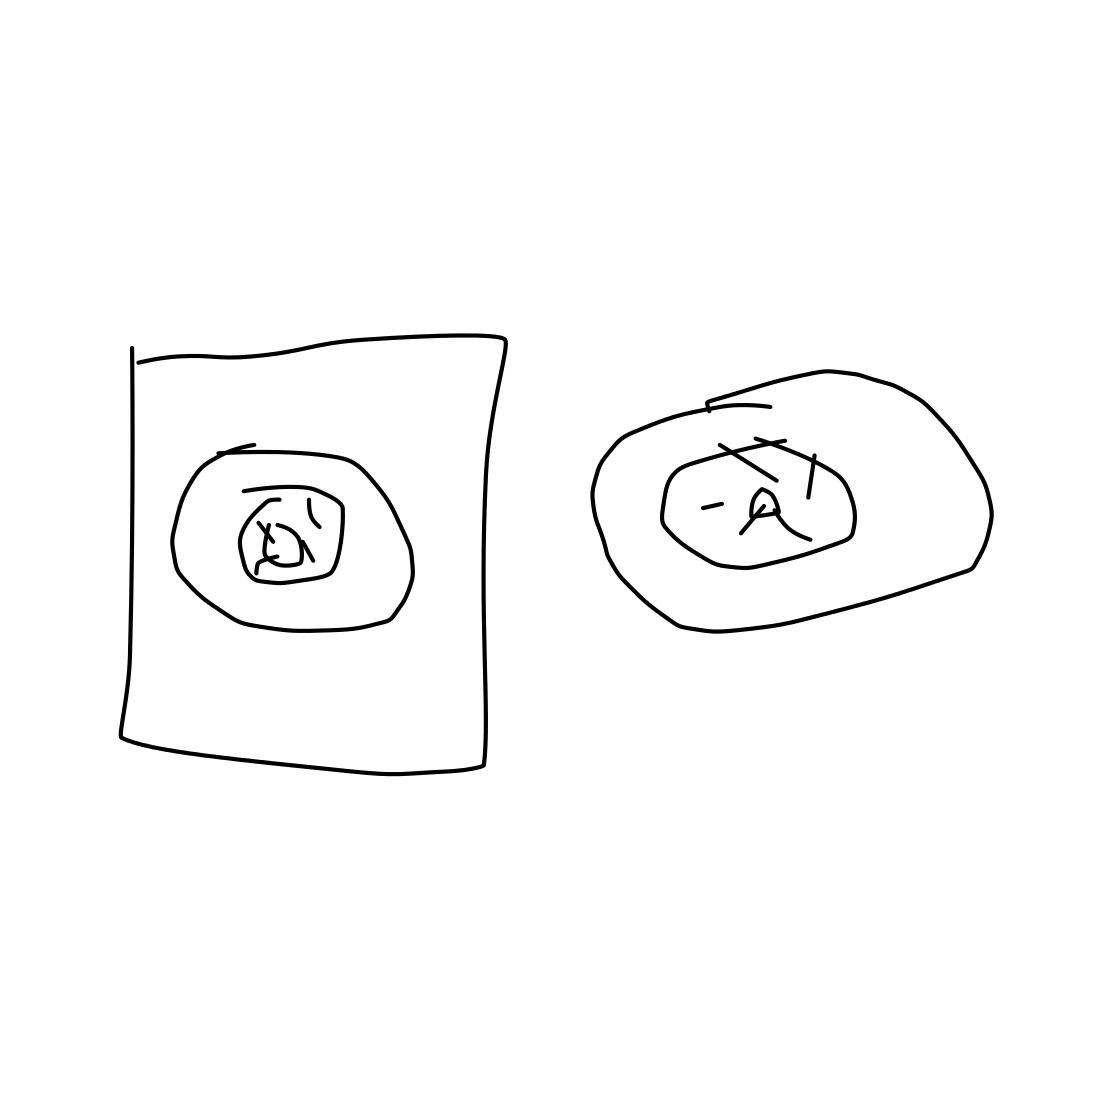Do these sketches appear to be part of a larger project or idea? Given their simplicity and the lack of additional information, it's hard to determine if they're part of a larger project. They might be standalone ideas or components of a sequence. Additional sketches or notes would help clarify their role in a broader context. 